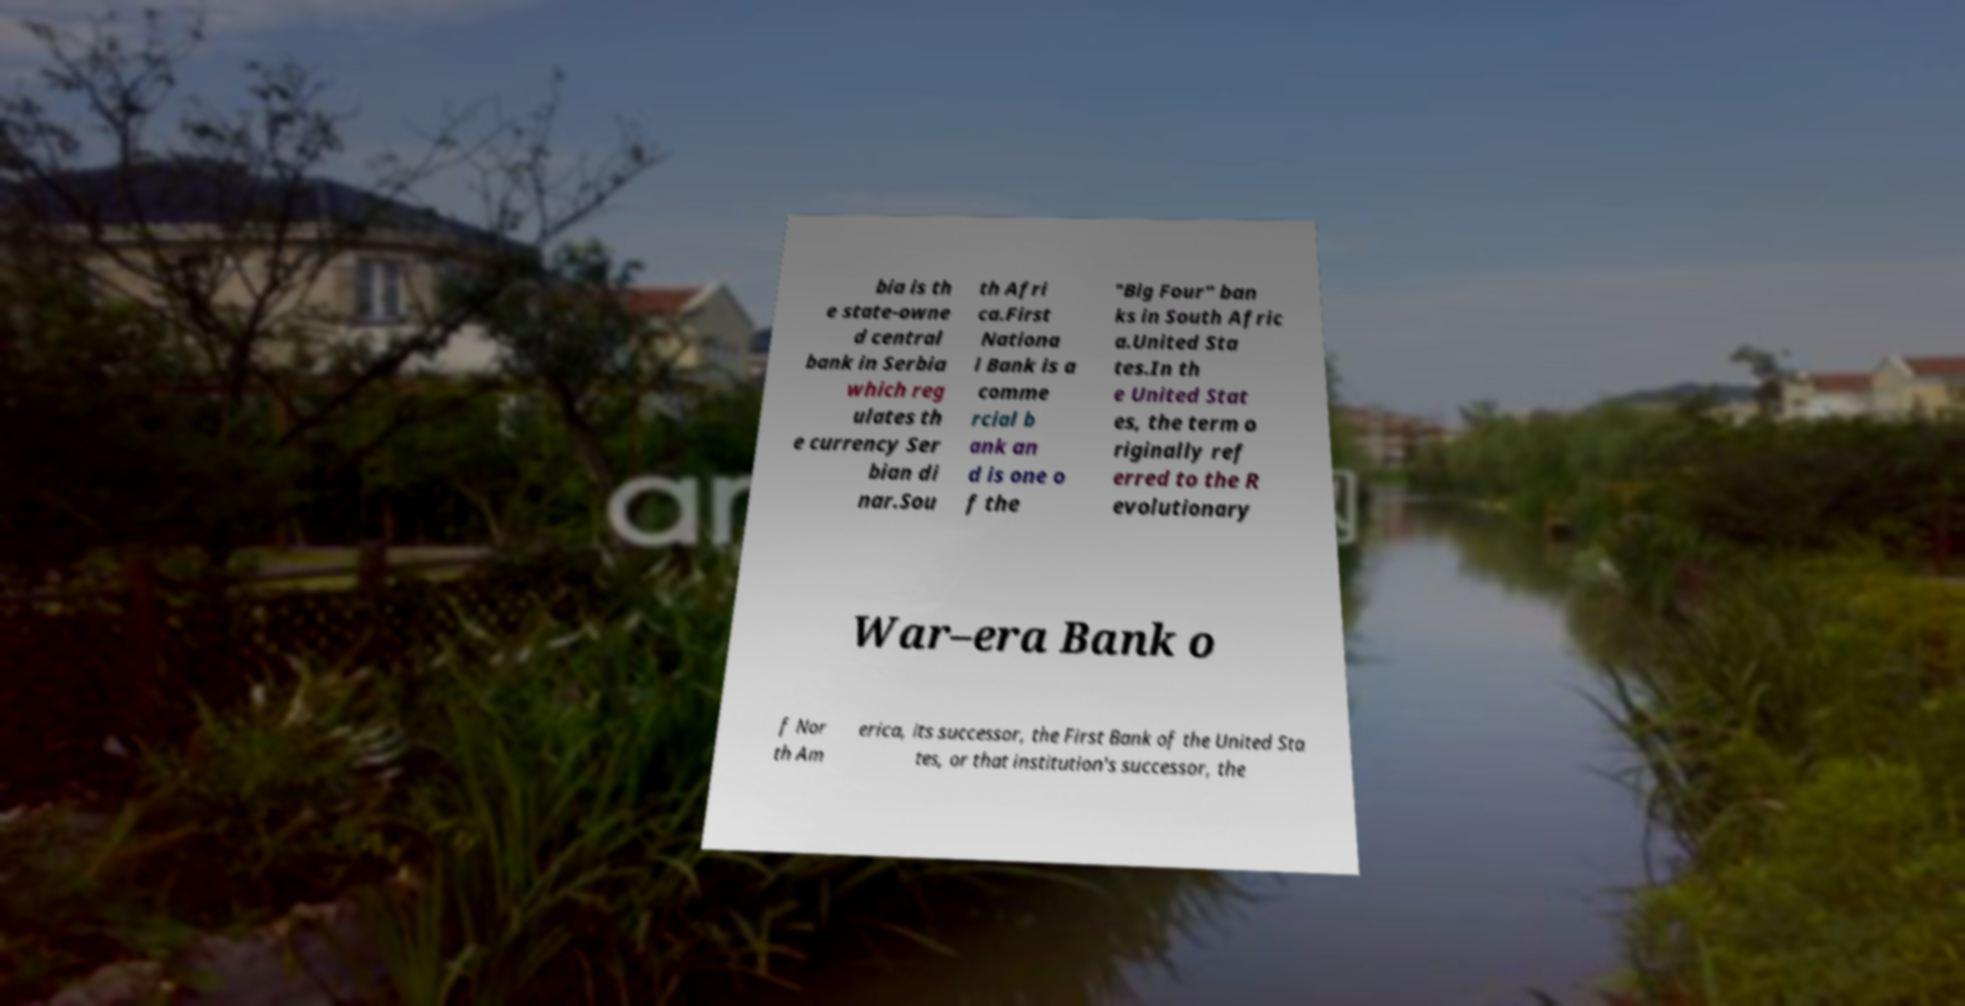Can you accurately transcribe the text from the provided image for me? bia is th e state-owne d central bank in Serbia which reg ulates th e currency Ser bian di nar.Sou th Afri ca.First Nationa l Bank is a comme rcial b ank an d is one o f the "Big Four" ban ks in South Afric a.United Sta tes.In th e United Stat es, the term o riginally ref erred to the R evolutionary War–era Bank o f Nor th Am erica, its successor, the First Bank of the United Sta tes, or that institution's successor, the 